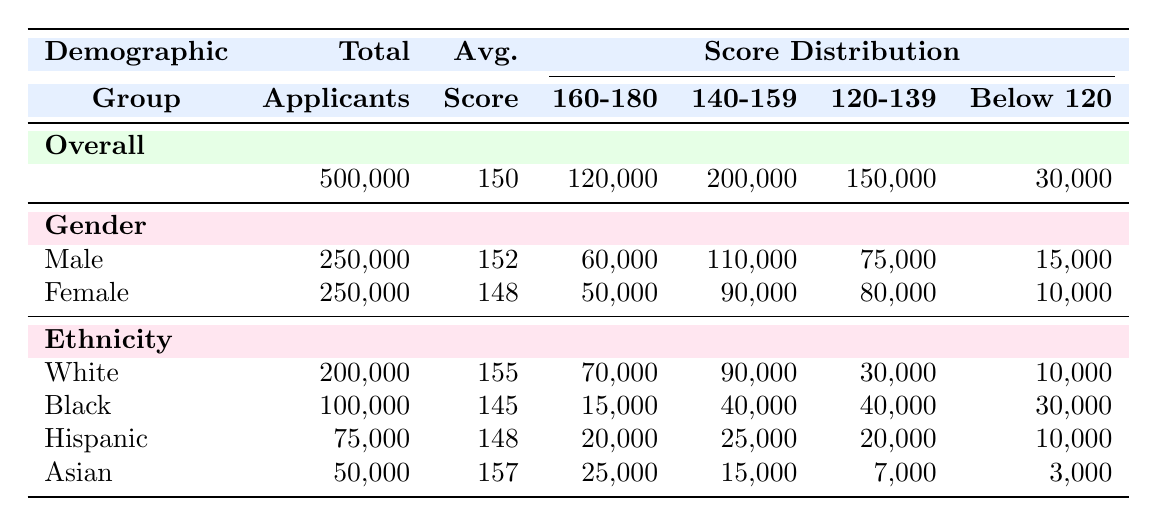What is the average LSAT score for female applicants? The average LSAT score for female applicants is provided directly in the "Female" row under the "Avg." column. It states that the average score is 148.
Answer: 148 How many total applicants are there for Black ethnicity? The table shows under the "Black" row that there are 100,000 total applicants listed.
Answer: 100000 What is the score distribution for applicants scoring between 140-159? To find this, refer to the overall score distribution and specifically to the "140-159" column, which shows a total of 200,000 applicants score within this range.
Answer: 200000 What is the difference between the average scores of male and female applicants? The average score for male applicants is 152 and for female applicants is 148. To find the difference, subtract 148 from 152: 152 - 148 = 4.
Answer: 4 Is the average LSAT score for Hispanic applicants higher than that for Black applicants? The average score for Hispanic applicants is 148, while for Black applicants it is 145. Since 148 is greater than 145, the statement is true.
Answer: Yes How many applicants scored below 120 across all demographics? To find this, we must refer to the "Below 120" row across all groups: 30,000 (Overall) and add the numbers from each demographic. Total = 15,000 (Male) + 10,000 (Female) + 30,000 (Black) + 10,000 (White) + 10,000 (Hispanic) + 3,000 (Asian) = 78,000.
Answer: 78000 Which demographic group has the highest average LSAT score? By examining the average scores listed for each demographic group: White (155), Black (145), Hispanic (148), and Asian (157), we see that White has the highest average score of 155.
Answer: White What percentage of overall applicants scored between 160-180? To find this percentage, divide the total number of applicants scoring in this range (120,000) by the total number of applicants (500,000) and multiply by 100. Percentage = (120,000 / 500,000) * 100 = 24%.
Answer: 24% How many applicants scored between 120-139 among Asian applicants? The score distribution column for the Asian demographic shows 7,000 applicants scored between 120-139.
Answer: 7000 